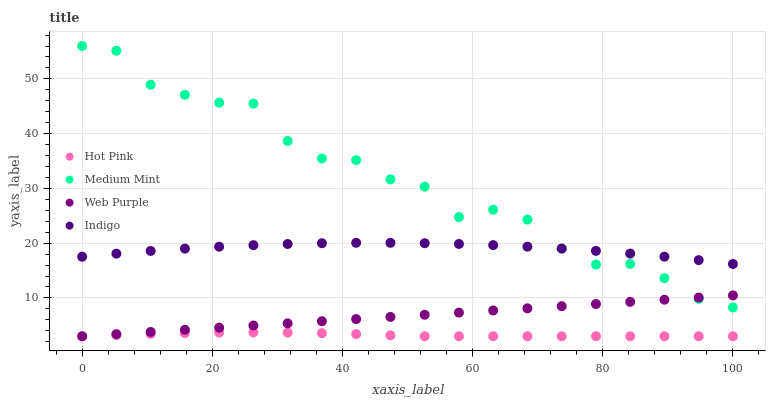Does Hot Pink have the minimum area under the curve?
Answer yes or no. Yes. Does Medium Mint have the maximum area under the curve?
Answer yes or no. Yes. Does Web Purple have the minimum area under the curve?
Answer yes or no. No. Does Web Purple have the maximum area under the curve?
Answer yes or no. No. Is Web Purple the smoothest?
Answer yes or no. Yes. Is Medium Mint the roughest?
Answer yes or no. Yes. Is Hot Pink the smoothest?
Answer yes or no. No. Is Hot Pink the roughest?
Answer yes or no. No. Does Web Purple have the lowest value?
Answer yes or no. Yes. Does Indigo have the lowest value?
Answer yes or no. No. Does Medium Mint have the highest value?
Answer yes or no. Yes. Does Web Purple have the highest value?
Answer yes or no. No. Is Hot Pink less than Medium Mint?
Answer yes or no. Yes. Is Indigo greater than Hot Pink?
Answer yes or no. Yes. Does Hot Pink intersect Web Purple?
Answer yes or no. Yes. Is Hot Pink less than Web Purple?
Answer yes or no. No. Is Hot Pink greater than Web Purple?
Answer yes or no. No. Does Hot Pink intersect Medium Mint?
Answer yes or no. No. 